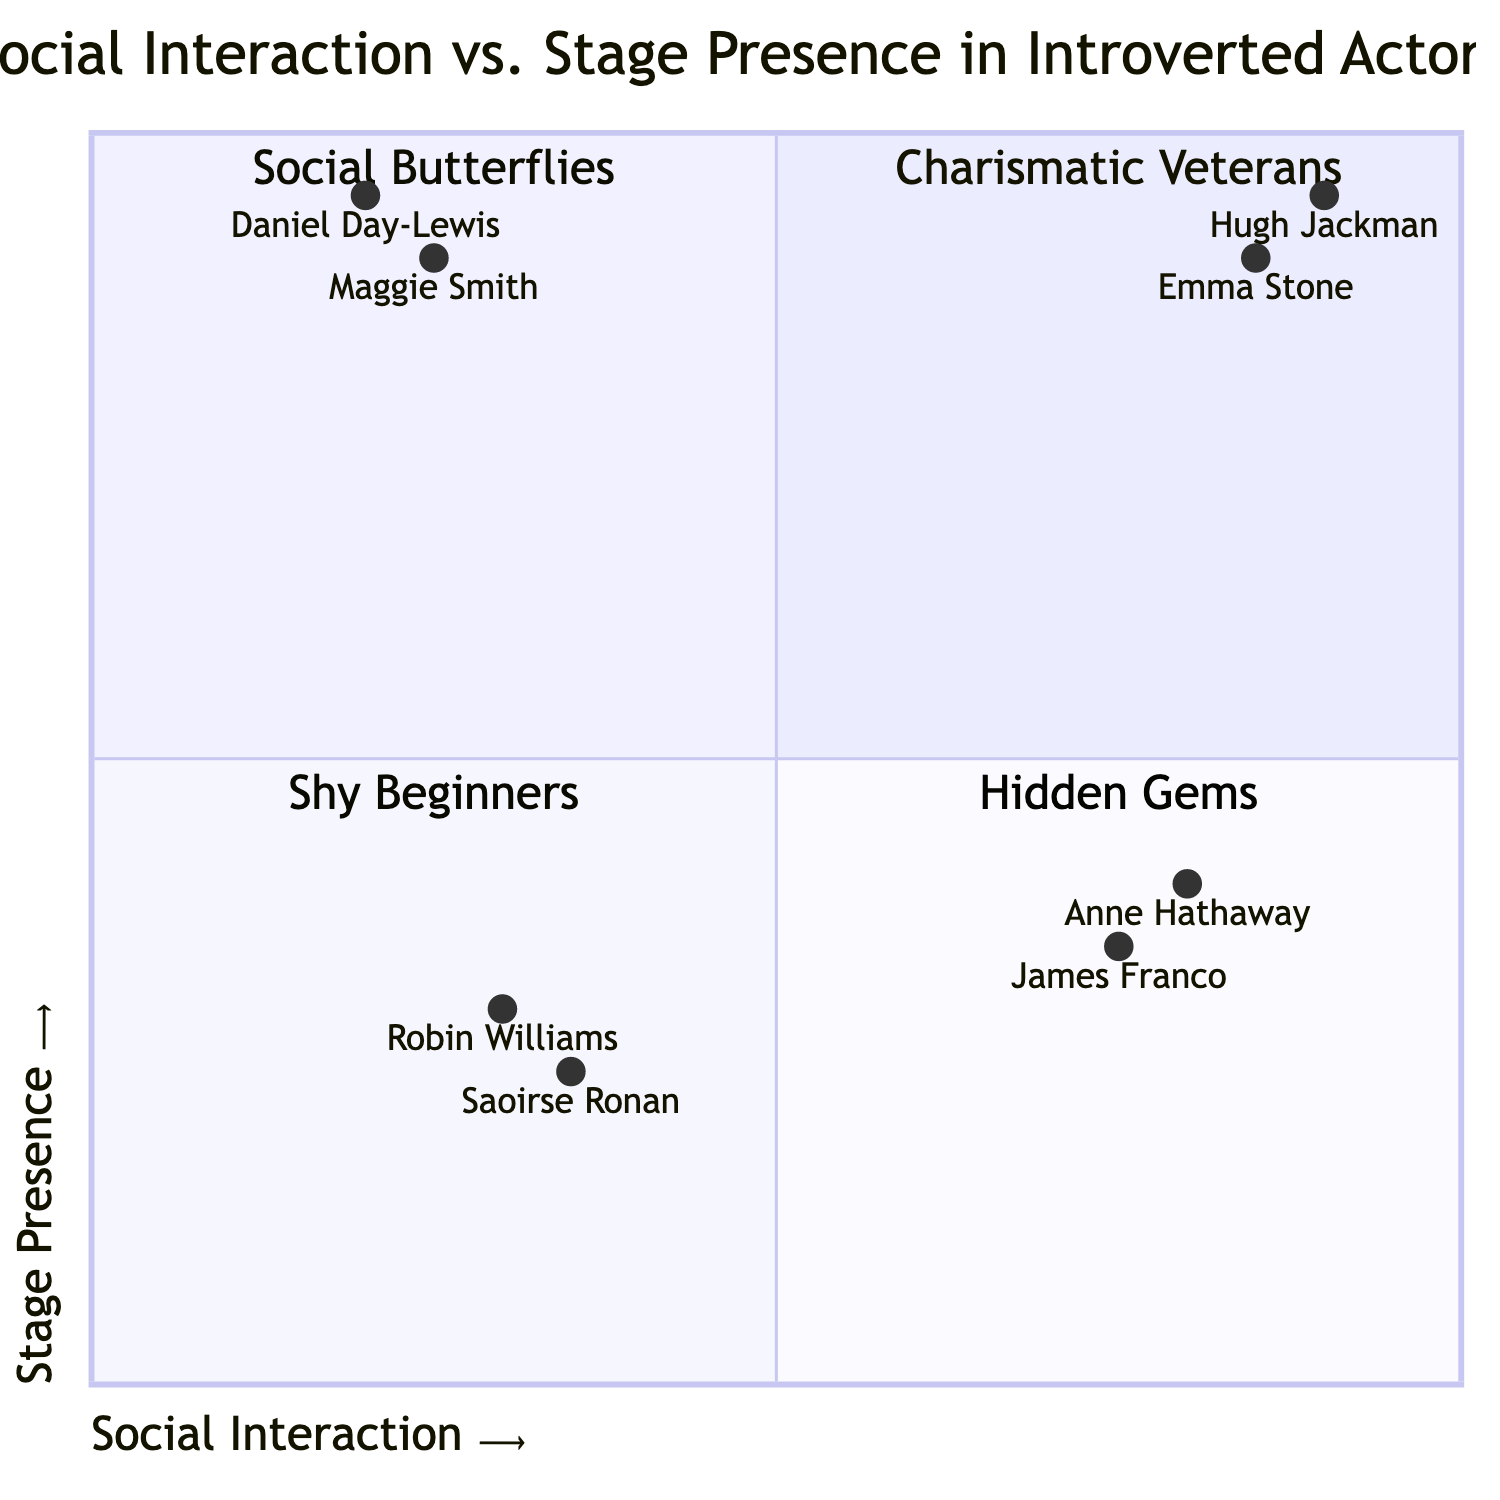What type of actors are found in the low social interaction and low stage presence quadrant? The quadrant shows "Shy Beginners," which includes individuals who are both introverted and still developing their stage presence.
Answer: Shy Beginners How many examples are listed for the "Hidden Gems" quadrant? The "Hidden Gems" quadrant has two notable examples listed: Daniel Day-Lewis and Maggie Smith.
Answer: 2 Which actor has the highest stage presence among the "Social Butterflies"? The diagram lists Anne Hathaway with a stage presence of 0.4 and James Franco with a stage presence of 0.35; therefore, Anne Hathaway has the highest stage presence in that quadrant.
Answer: Anne Hathaway What is the stage presence score of Hugh Jackman? The diagram indicates that Hugh Jackman has a stage presence score of 0.95.
Answer: 0.95 Which quadrant contains actors that excel both socially and on stage? The "Charismatic Veterans" quadrant is where actors who excel in both areas are found.
Answer: Charismatic Veterans How many actors are in the "Shy Beginners" category? The diagram provides two examples of actors categorized as "Shy Beginners": early career Robin Williams and a young Saoirse Ronan.
Answer: 2 Who is considered a "Hidden Gem"? Daniel Day-Lewis is an example of a "Hidden Gem" actor, showcasing powerful performance despite being introverted.
Answer: Daniel Day-Lewis Which quadrant is likely to contain actors who can develop their stage presence? The "Shy Beginners" quadrant is likely to contain actors who are still developing their stage presence with untapped potential.
Answer: Shy Beginners 